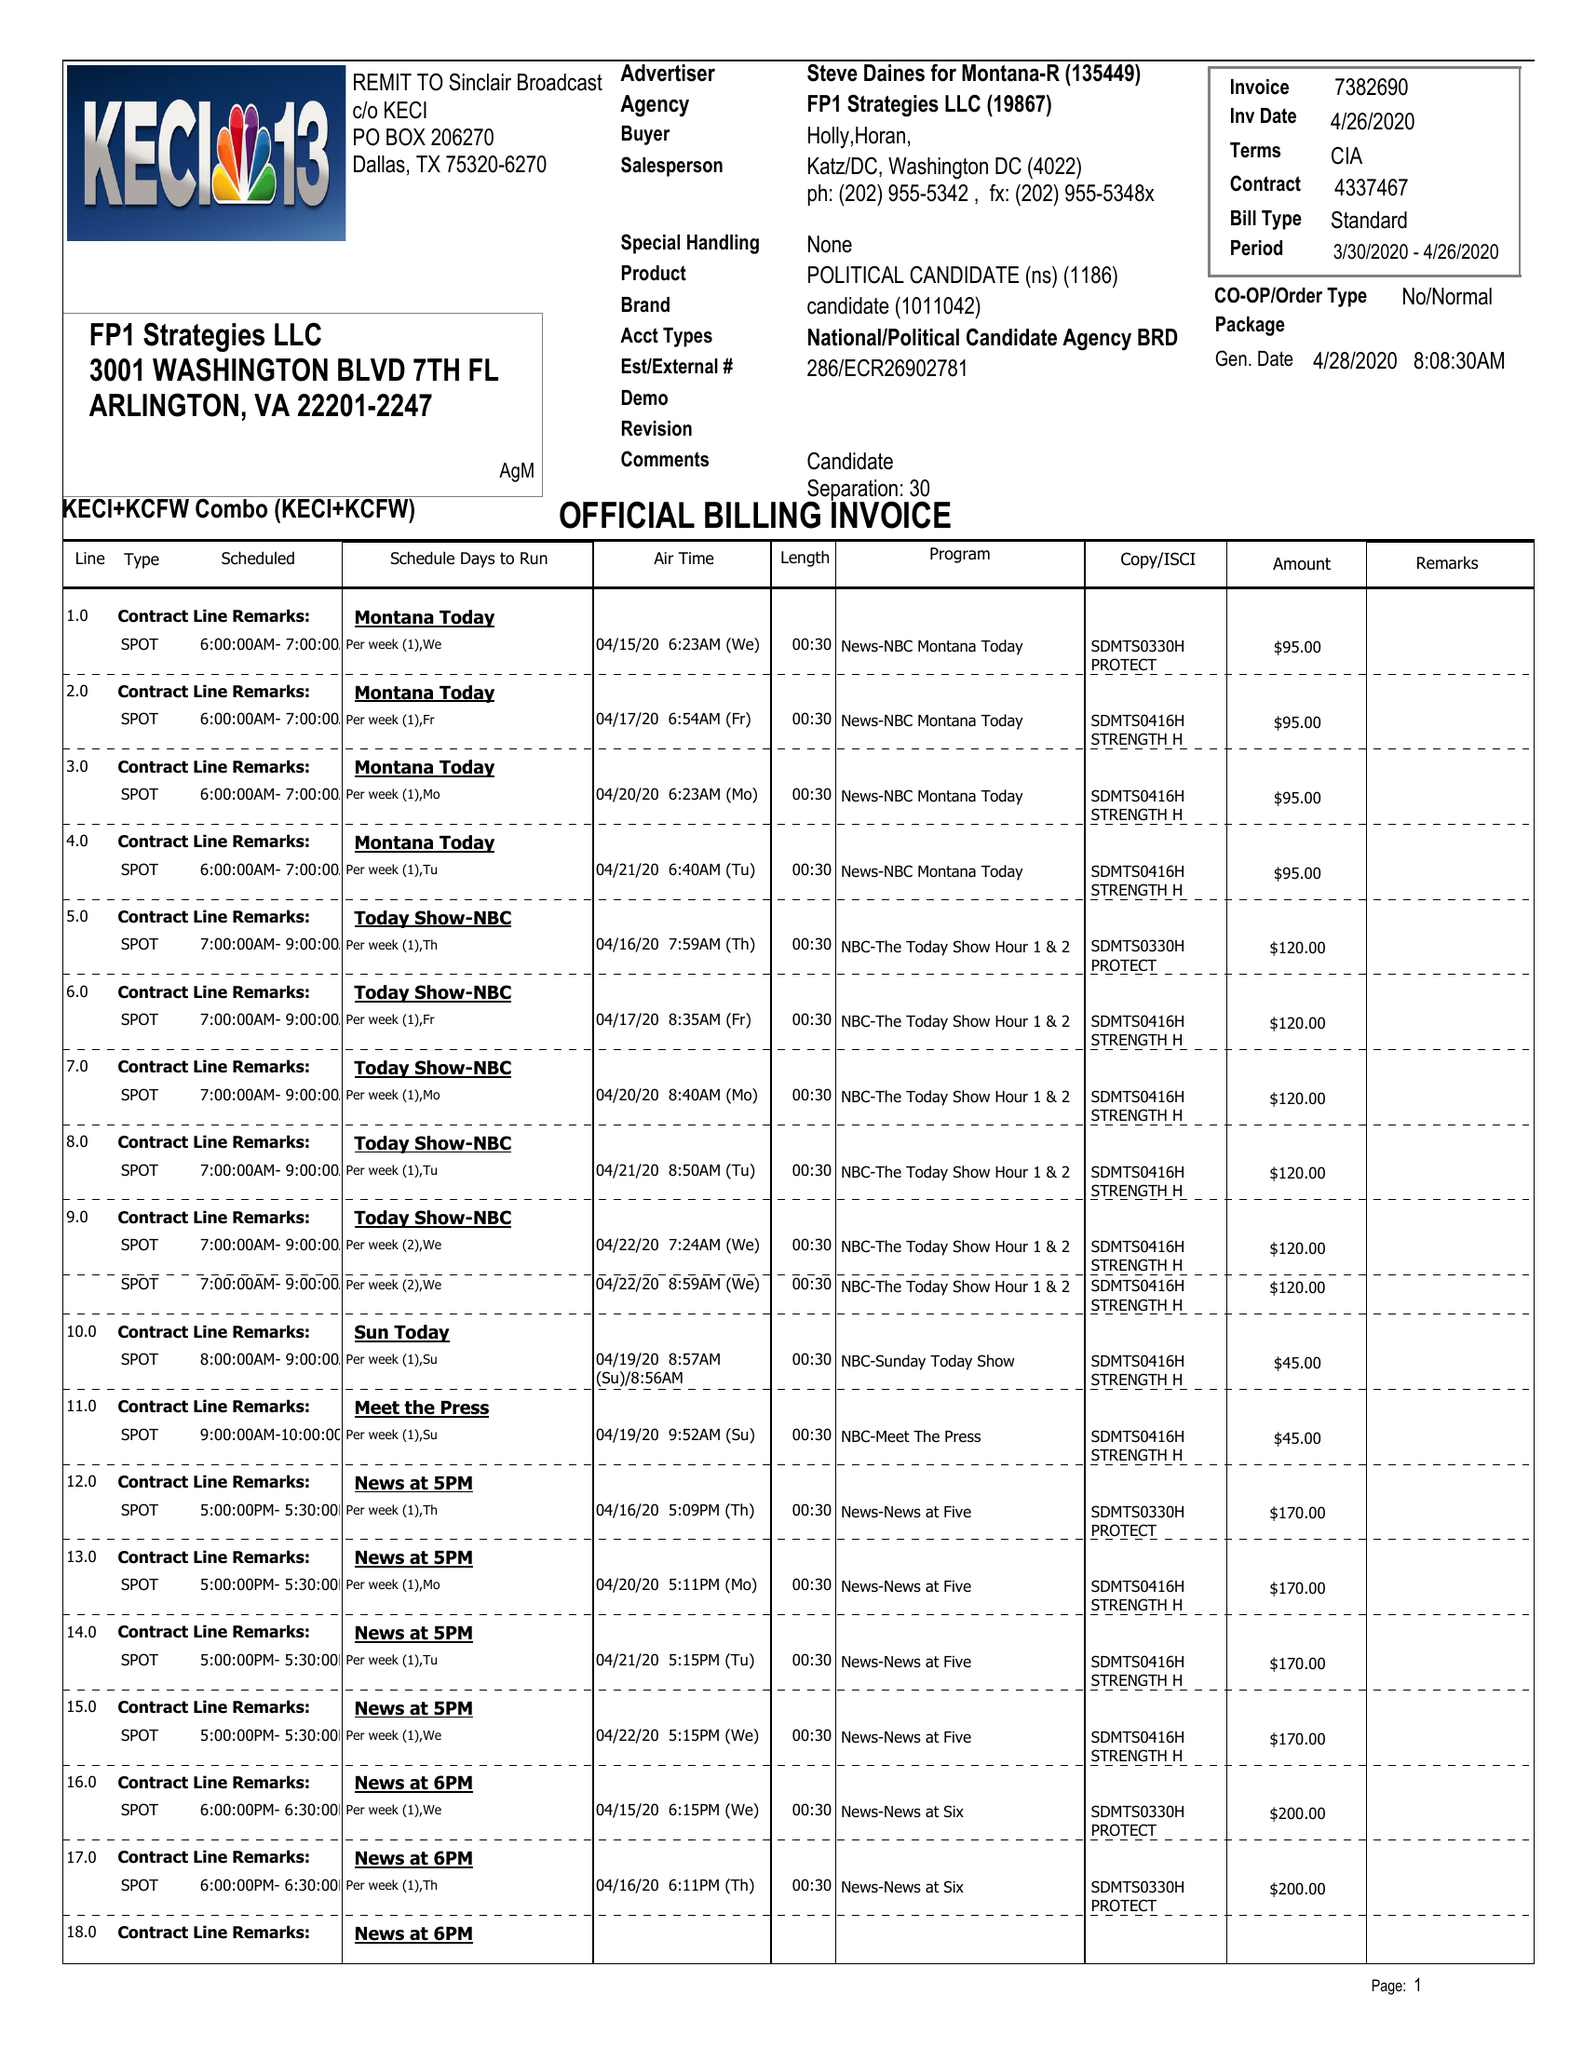What is the value for the contract_num?
Answer the question using a single word or phrase. 4337467 